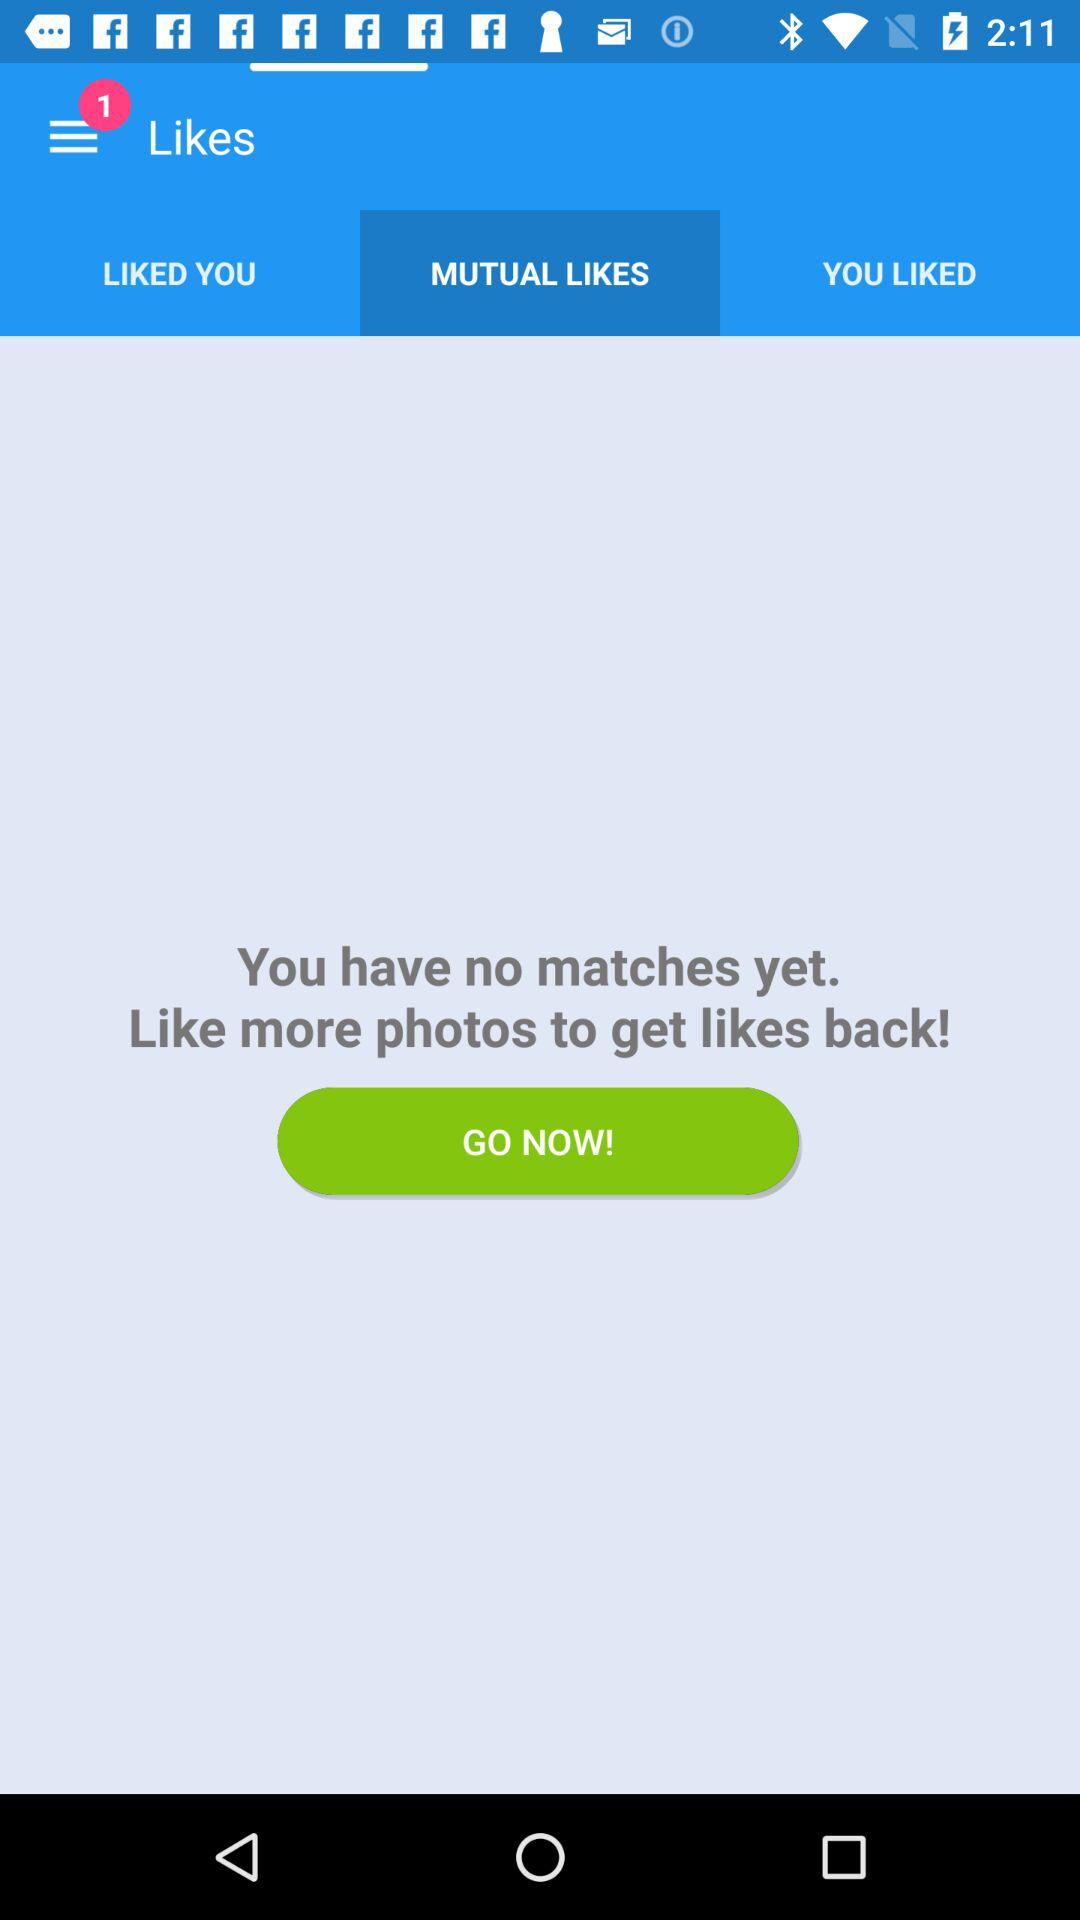Which tab is selected? The selected tab is "MUTUAL LIKES". 